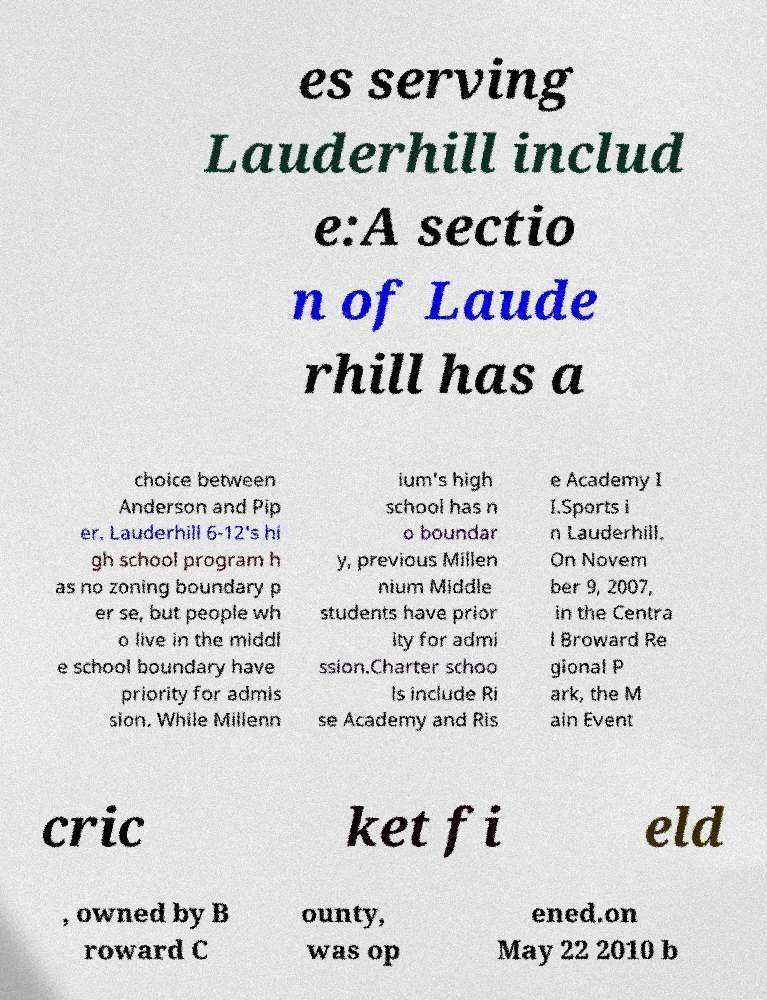Please read and relay the text visible in this image. What does it say? es serving Lauderhill includ e:A sectio n of Laude rhill has a choice between Anderson and Pip er. Lauderhill 6-12's hi gh school program h as no zoning boundary p er se, but people wh o live in the middl e school boundary have priority for admis sion. While Millenn ium's high school has n o boundar y, previous Millen nium Middle students have prior ity for admi ssion.Charter schoo ls include Ri se Academy and Ris e Academy I I.Sports i n Lauderhill. On Novem ber 9, 2007, in the Centra l Broward Re gional P ark, the M ain Event cric ket fi eld , owned by B roward C ounty, was op ened.on May 22 2010 b 